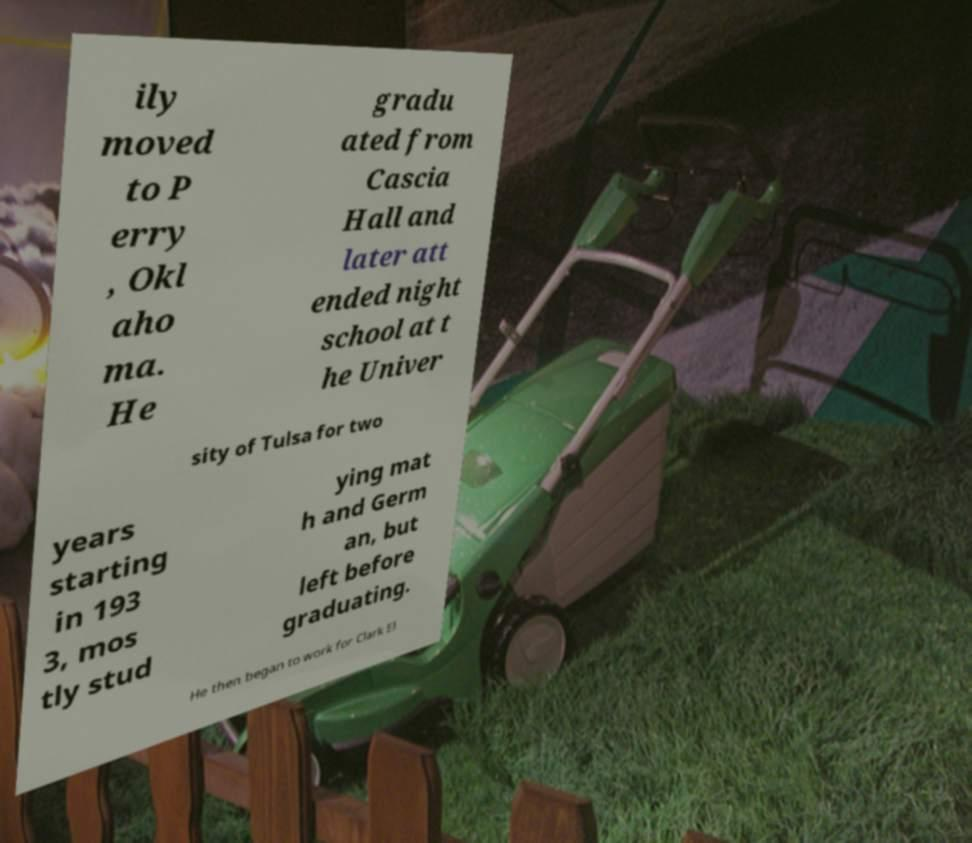What messages or text are displayed in this image? I need them in a readable, typed format. ily moved to P erry , Okl aho ma. He gradu ated from Cascia Hall and later att ended night school at t he Univer sity of Tulsa for two years starting in 193 3, mos tly stud ying mat h and Germ an, but left before graduating. He then began to work for Clark El 